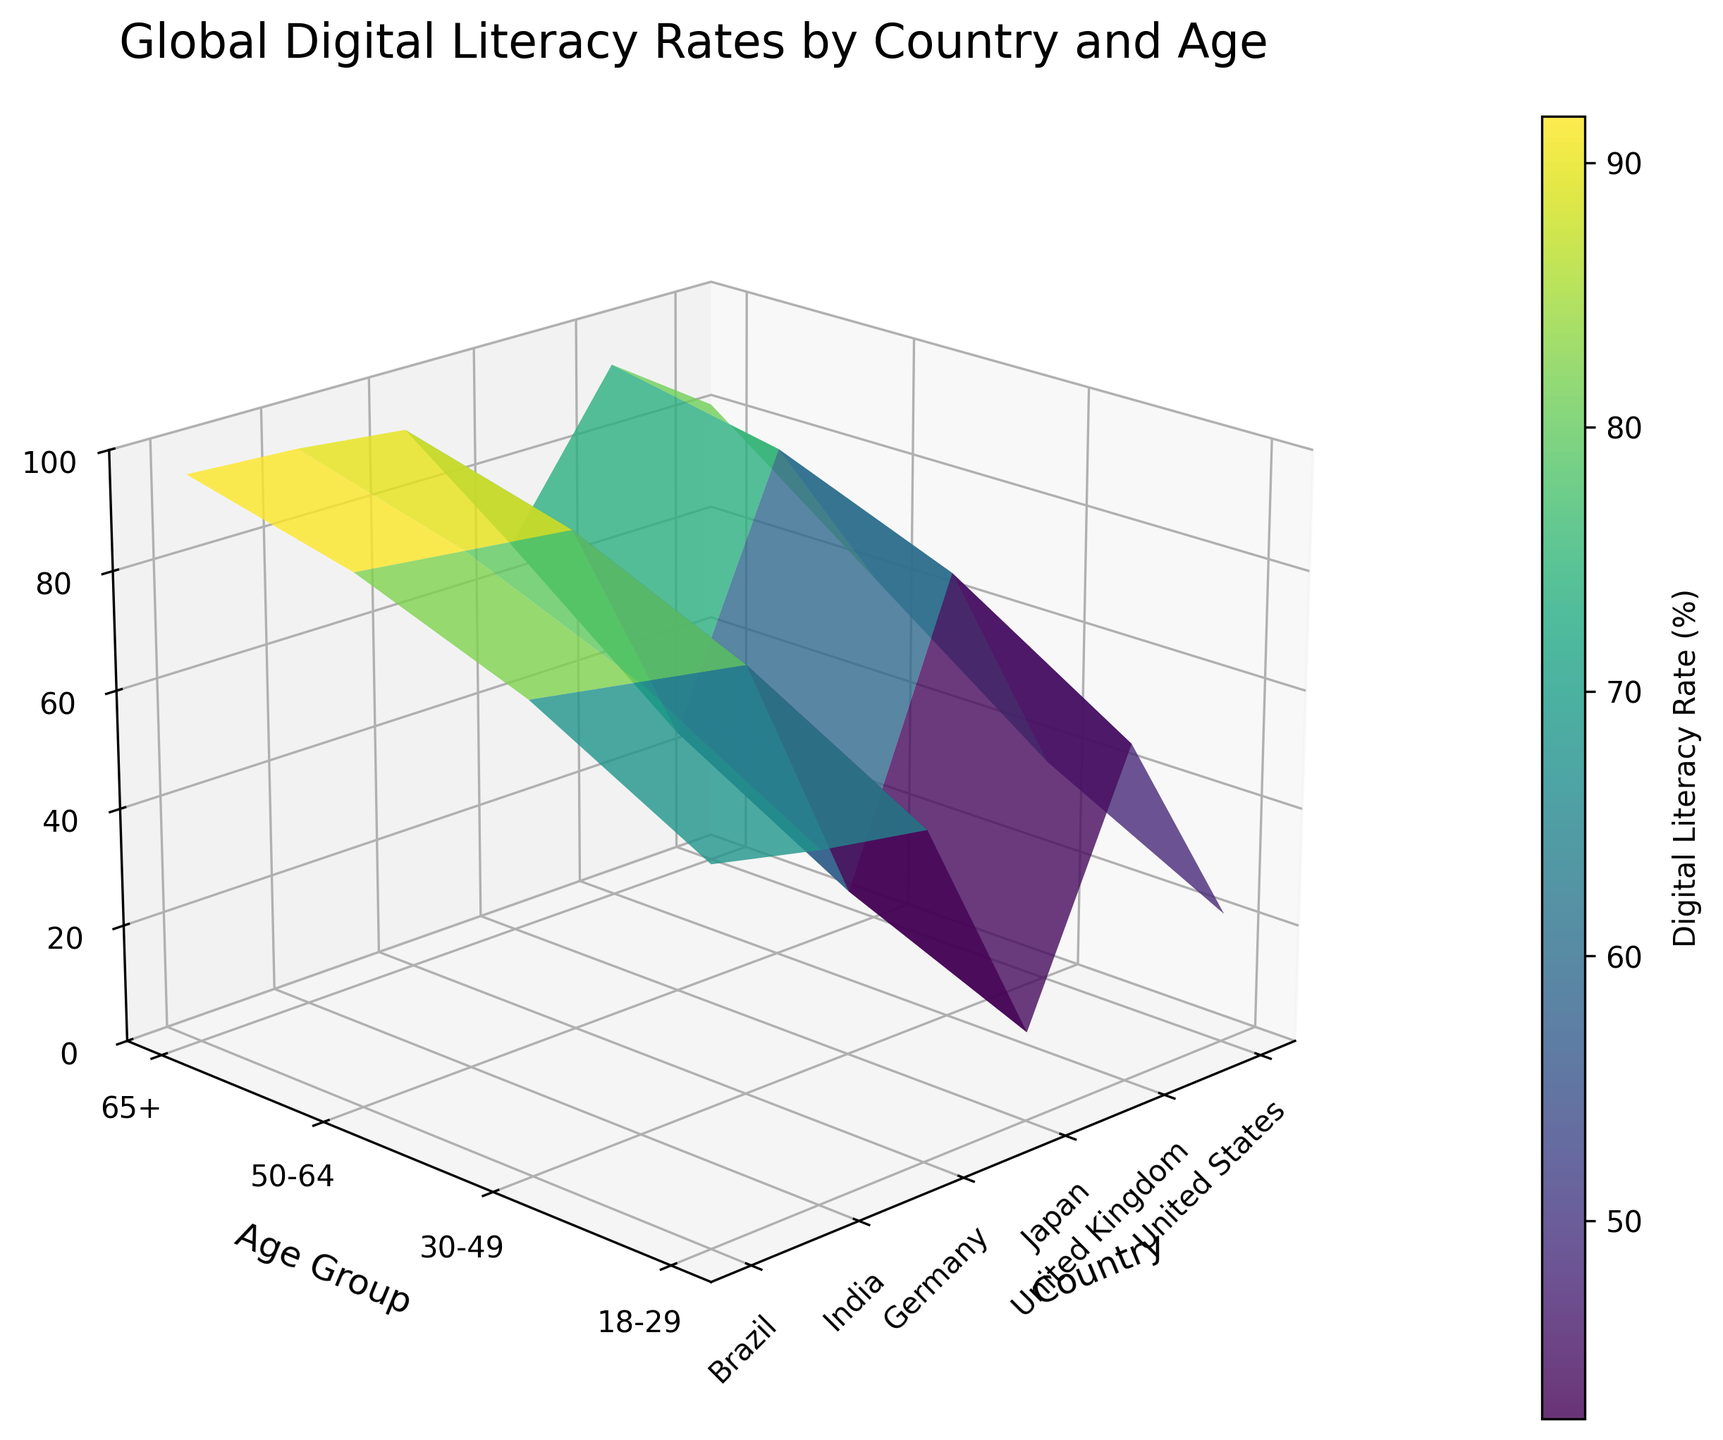Which country has the highest digital literacy rate for the 18-29 age group? Look at the highest point on the z-axis for the 18-29 age group (y-axis) and identify the corresponding country (x-axis).
Answer: United States Which country has the lowest digital literacy rate for the 65+ age group? Look at the lowest point on the z-axis for the 65+ age group (y-axis) and identify the corresponding country (x-axis).
Answer: India What colors are used to depict the digital literacy rates? The colors are variations of a single color map (viridis), where lighter shades represent higher rates, and darker shades represent lower rates.
Answer: Various shades of green and blue What is the digital literacy rate for the United Kingdom for the 50-64 age group? Locate the United Kingdom on the x-axis and the 50-64 age group on the y-axis, then find the z-axis value at this coordinate.
Answer: 75 How does Japan's digital literacy rate for the 65+ age group compare to Germany's? Compare the z-axis values for Japan and Germany in the 65+ age group on the y-axis.
Answer: Japan's rate is slightly lower Which age group has the highest digital literacy rates across all countries? Look for the highest values on the z-axis across all age groups on the y-axis for all countries on the x-axis and identify the age group.
Answer: 18-29 Is there a general trend in digital literacy rates across different age groups? Identify any patterns in the z-axis values for each age group (y-axis) across all countries (x-axis).
Answer: Digital literacy generally decreases with age What is the average digital literacy rate for the 50-64 age group across all countries? Add the digital literacy rates for the 50-64 age group across all countries and divide by the number of countries. (78+75+72+76+28+38) / 6.
Answer: 61.2 What is the difference between digital literacy rates of Brazil and India for the 30-49 age group? Subtract India's digital literacy rate for the 30-49 age group from Brazil's digital literacy rate for the same age group. (60 - 45).
Answer: 15 How does the digital literacy rate of the United States for the 30-49 age group compare to the United Kingdom's for the 65+ age group? Locate the z-axis value for the United States for the 30-49 age group and compare it to the United Kingdom's for the 65+ age group.
Answer: The United States rate is much higher 